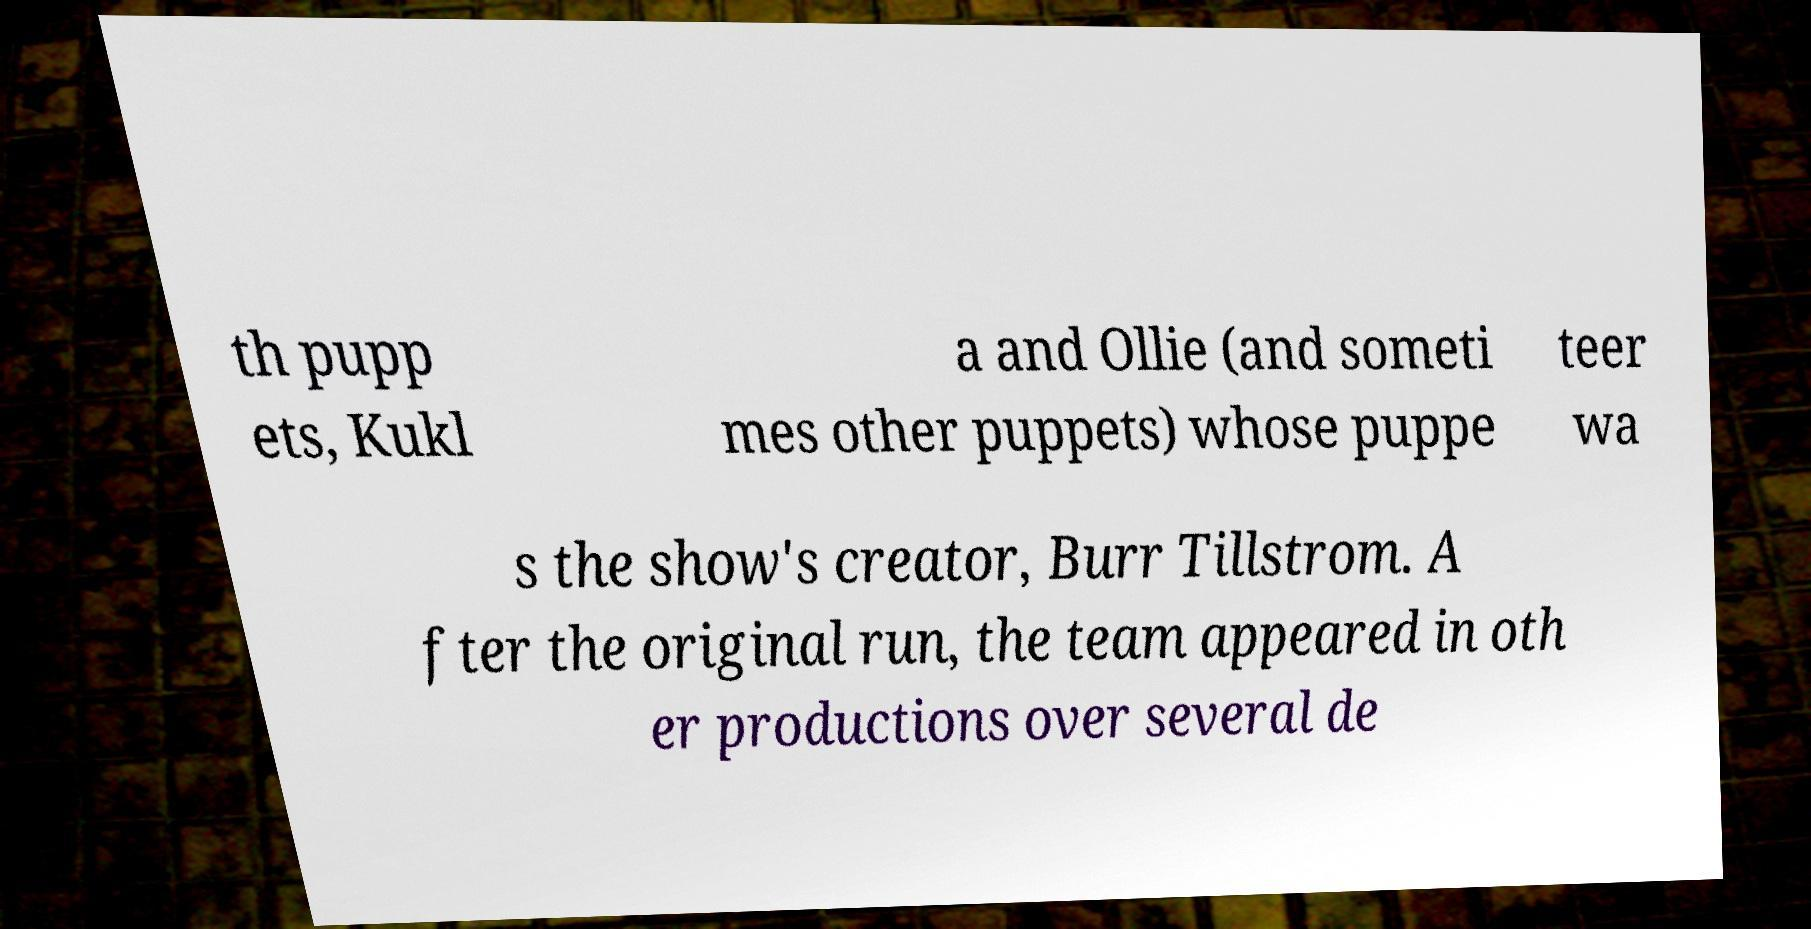I need the written content from this picture converted into text. Can you do that? th pupp ets, Kukl a and Ollie (and someti mes other puppets) whose puppe teer wa s the show's creator, Burr Tillstrom. A fter the original run, the team appeared in oth er productions over several de 